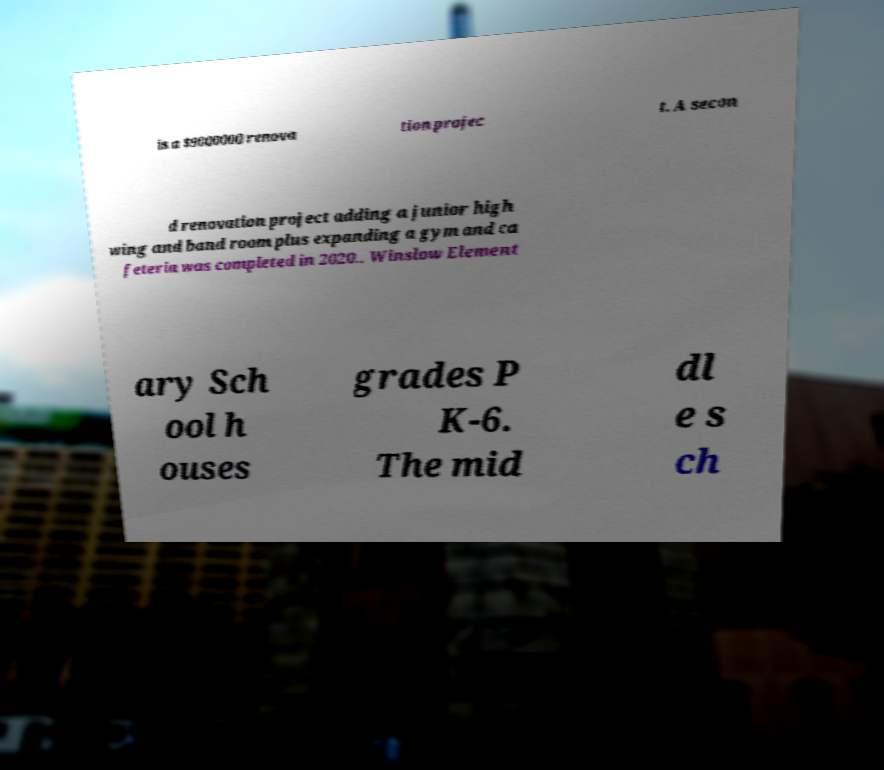What messages or text are displayed in this image? I need them in a readable, typed format. is a $9000000 renova tion projec t. A secon d renovation project adding a junior high wing and band room plus expanding a gym and ca feteria was completed in 2020.. Winslow Element ary Sch ool h ouses grades P K-6. The mid dl e s ch 